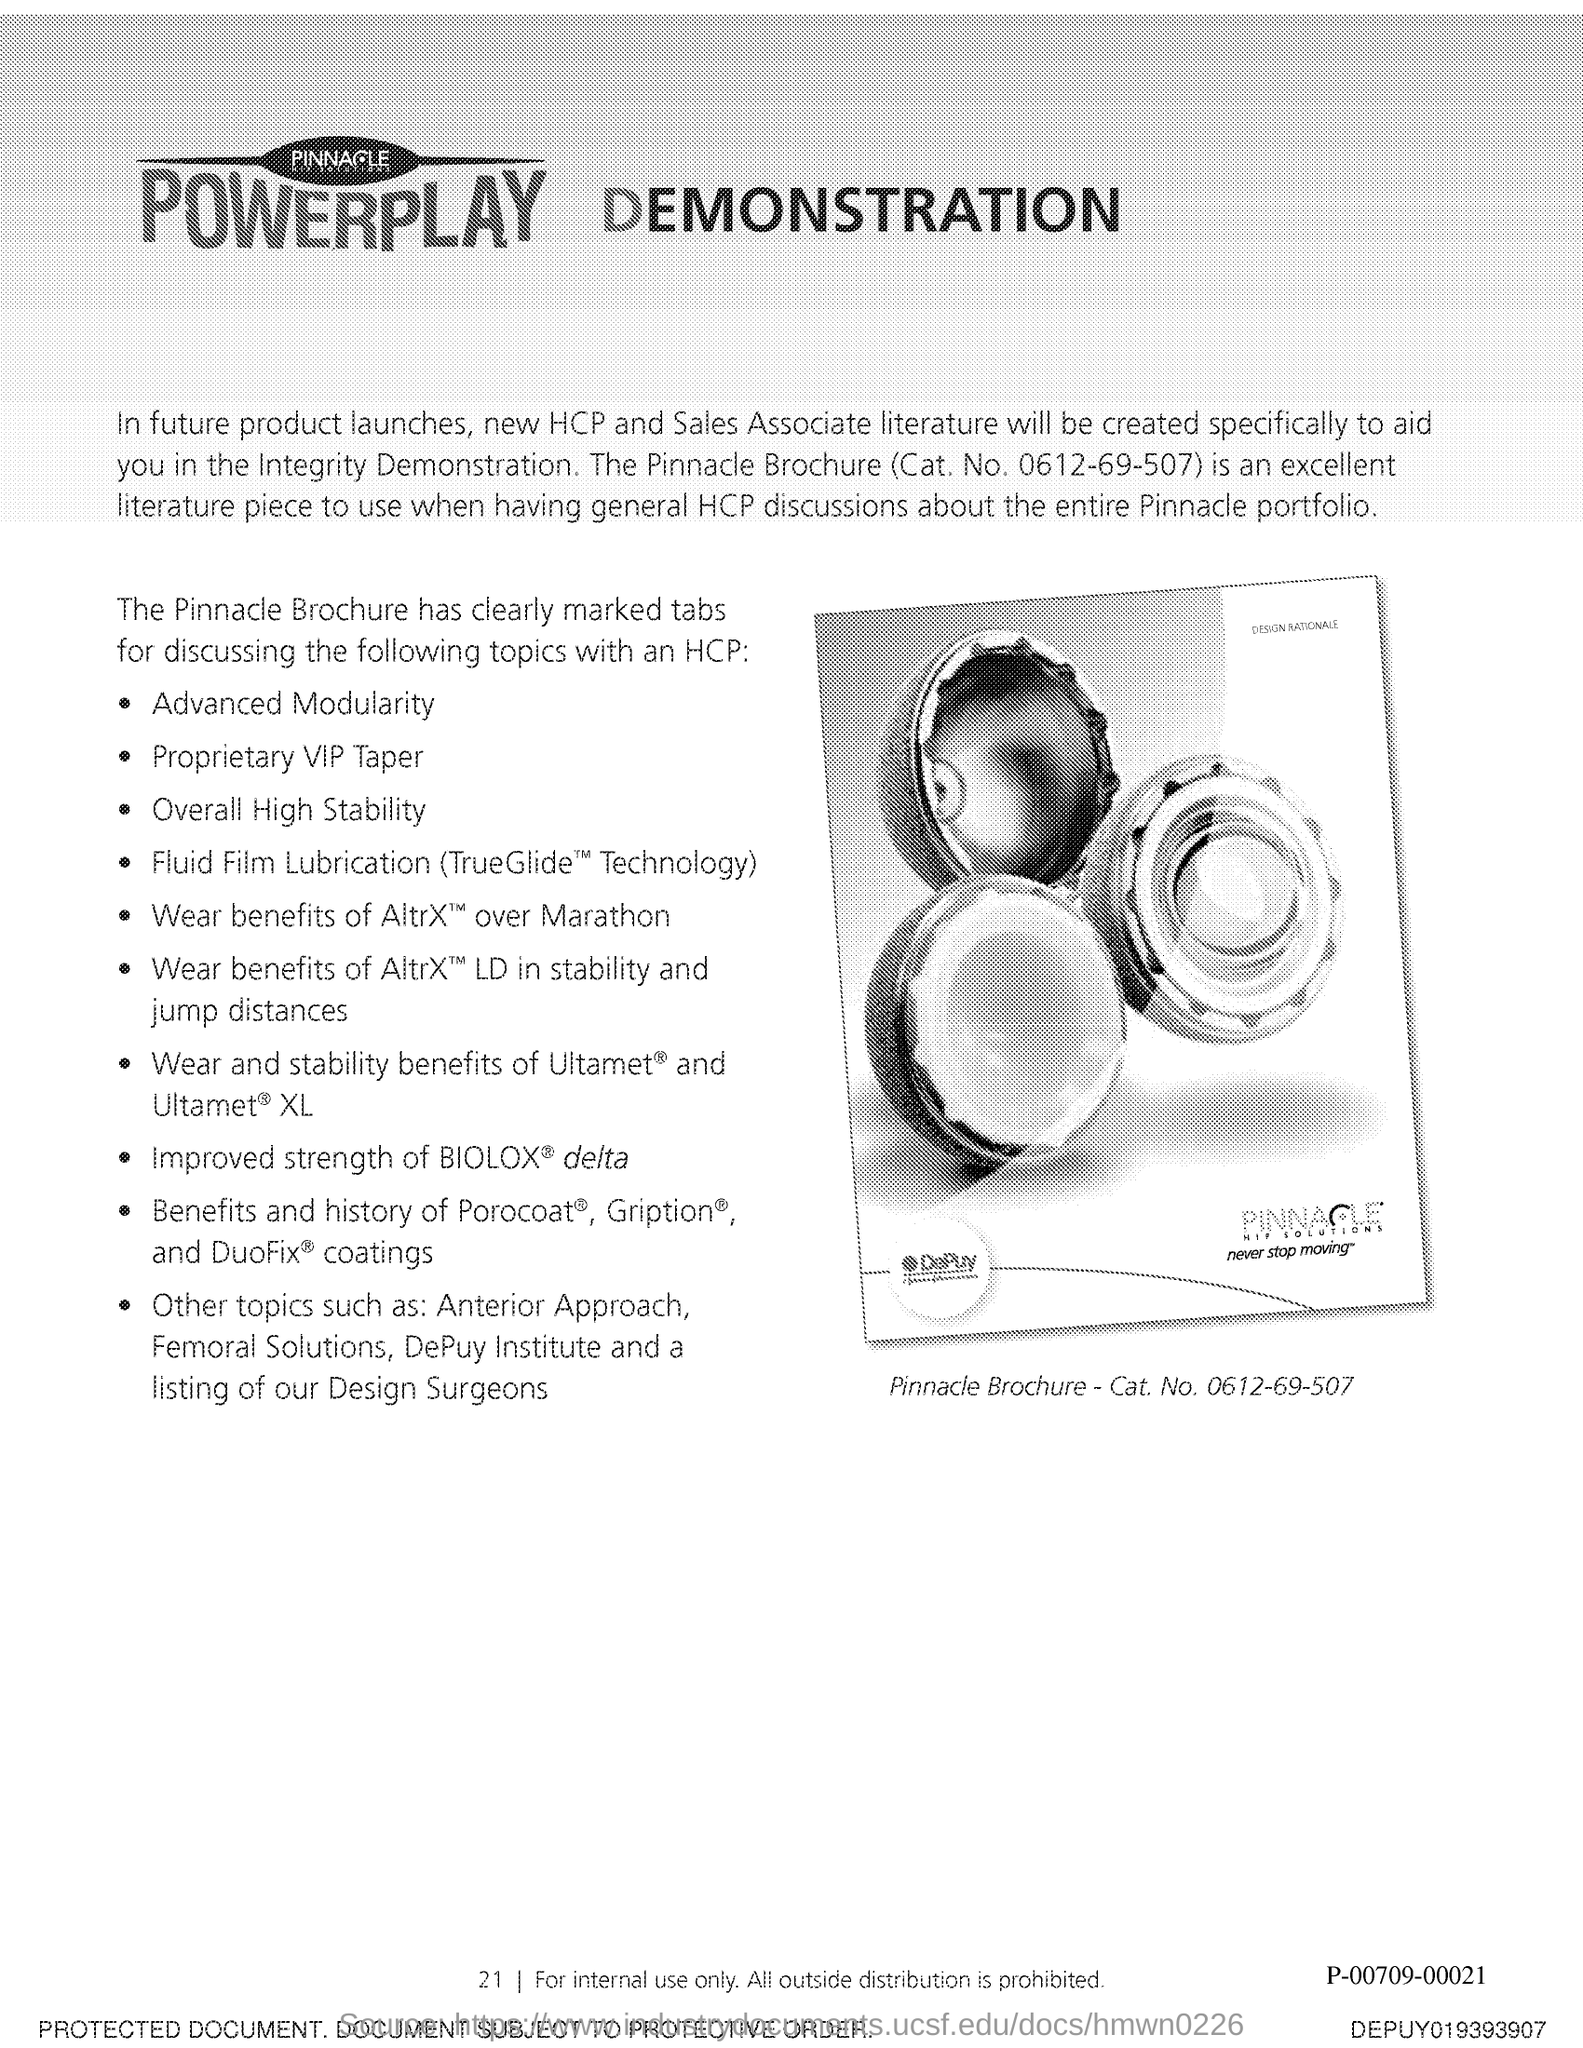Draw attention to some important aspects in this diagram. The Pinnacle Brochure Catalog Number is 0612-69-507. It is recommended to use the Pinnacle Brochure as an excellent literature piece when having general HCP discussions about the entire Pinnacle Portfolio. 